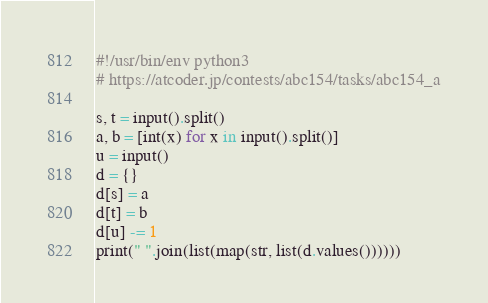<code> <loc_0><loc_0><loc_500><loc_500><_Python_>#!/usr/bin/env python3
# https://atcoder.jp/contests/abc154/tasks/abc154_a

s, t = input().split()
a, b = [int(x) for x in input().split()]
u = input()
d = {}
d[s] = a
d[t] = b
d[u] -= 1
print(" ".join(list(map(str, list(d.values())))))
</code> 